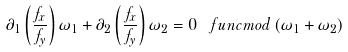Convert formula to latex. <formula><loc_0><loc_0><loc_500><loc_500>\partial _ { 1 } \left ( \frac { f _ { x } } { f _ { y } } \right ) \omega _ { 1 } + \partial _ { 2 } \left ( \frac { f _ { x } } { f _ { y } } \right ) \omega _ { 2 } = 0 \, \ f u n c { m o d } \, ( \omega _ { 1 } + \omega _ { 2 } )</formula> 